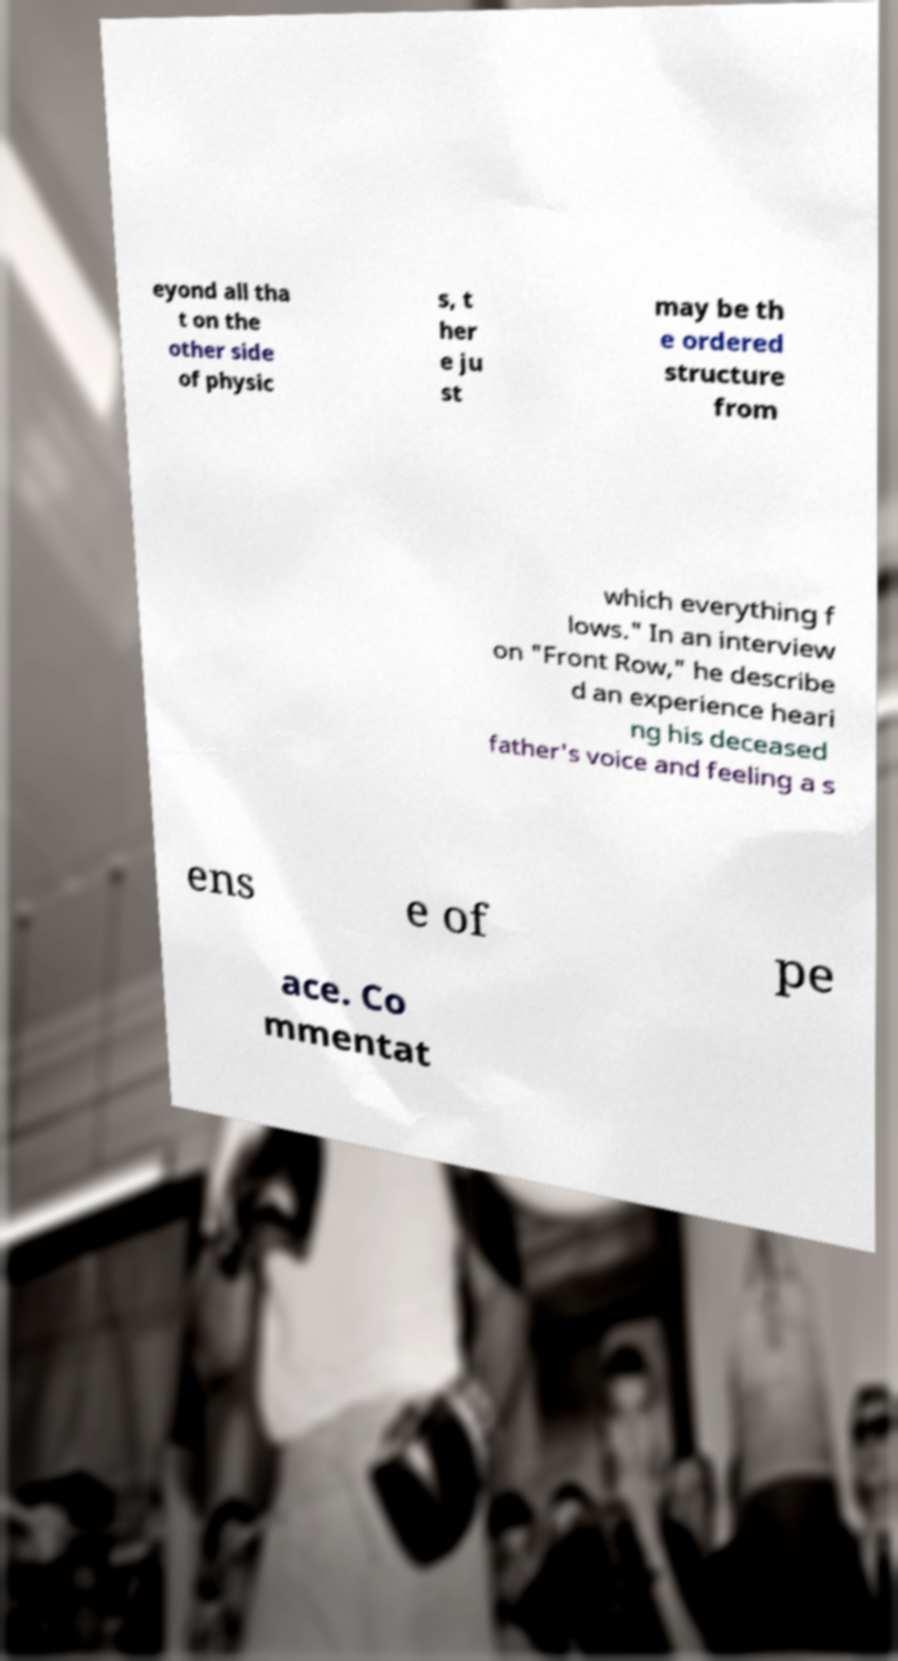Please read and relay the text visible in this image. What does it say? eyond all tha t on the other side of physic s, t her e ju st may be th e ordered structure from which everything f lows." In an interview on "Front Row," he describe d an experience heari ng his deceased father's voice and feeling a s ens e of pe ace. Co mmentat 